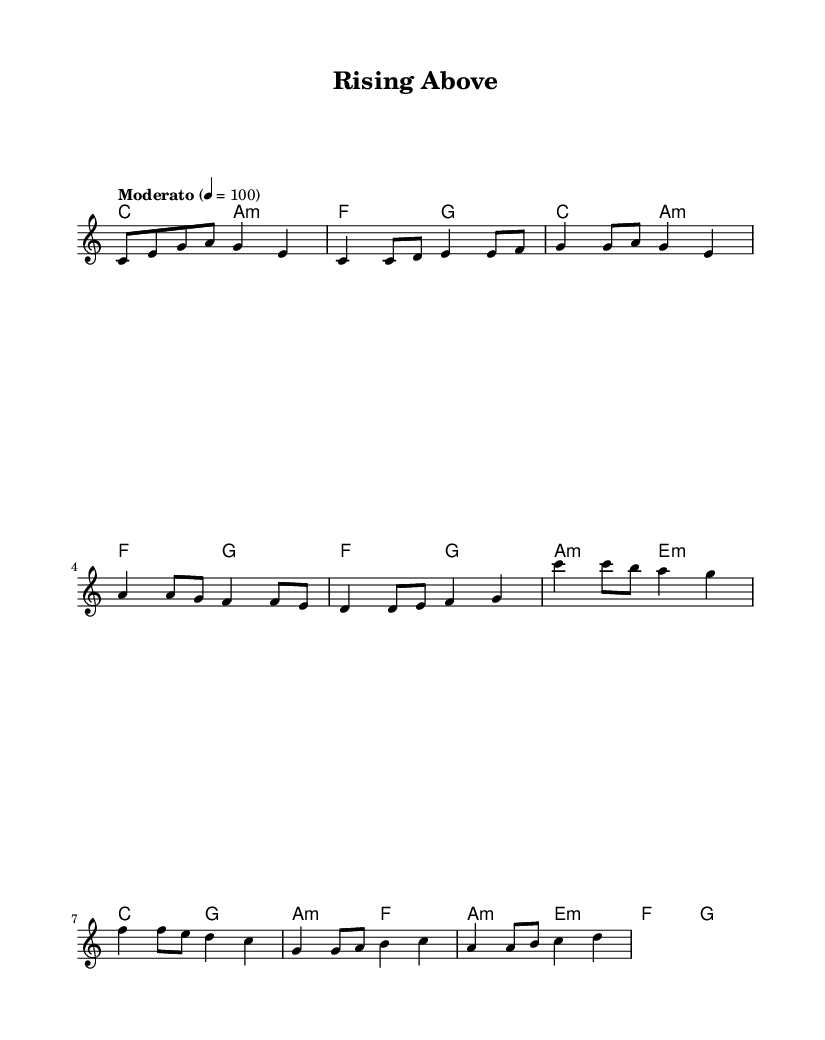What is the key signature of this music? The key signature is C major, which has no sharps or flats.
Answer: C major What is the time signature? The time signature is 4/4, which means there are four beats in each measure.
Answer: 4/4 What is the tempo marking for the piece? The tempo marking is "Moderato," indicating a moderate speed. The numeral indicates that the beats should be at a rate of 100 beats per minute.
Answer: Moderato How many measures are in the chorus? The chorus is comprised of four measures, as indicated by the structural breakdown of the lyrics and melody.
Answer: 4 What is the primary chord used in the verse? The primary chord used during the verse is C major, as shown consistently in the chord progression throughout that section.
Answer: C major Identify the type of anthem this music represents. This piece is a resilience anthem, as the lyrics and overall message focus on overcoming struggles and celebrating personal growth and strength.
Answer: Resilience What is the relationship between the pre-chorus and the chorus in terms of musical transition? The pre-chorus builds anticipation leading into the chorus by emphasizing a tonal shift and lyrical progression, preparing the listener for the uplifting resolution in the chorus.
Answer: Transition 